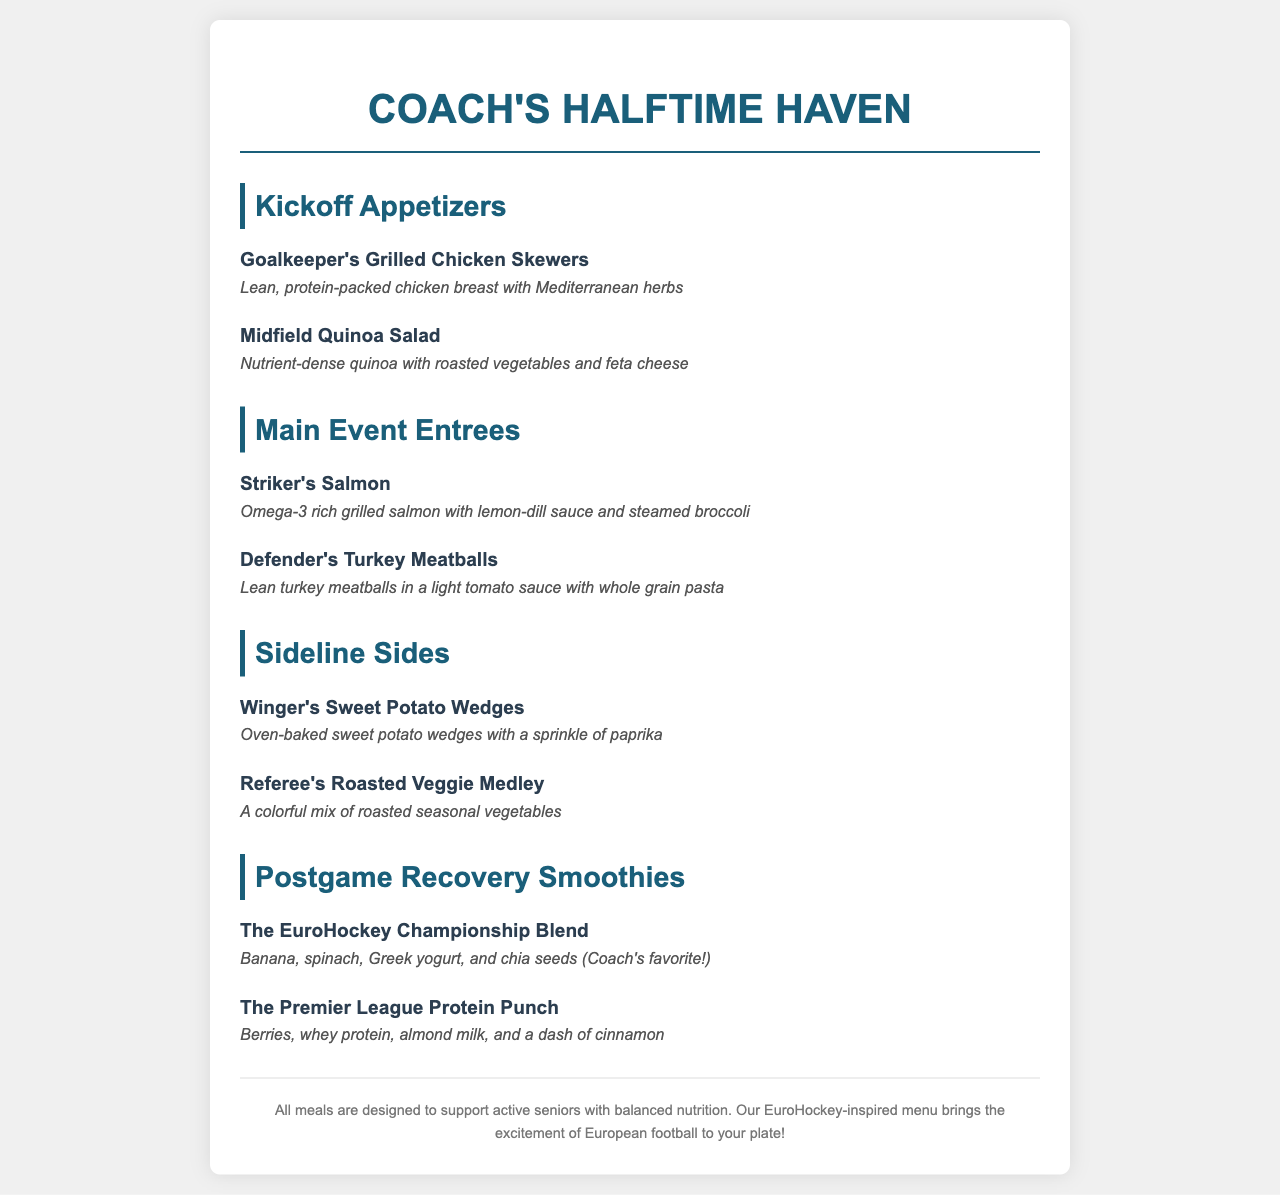What is the title of the menu? The title can be found at the top of the document and reads “Coach's Halftime Haven Menu.”
Answer: Coach's Halftime Haven How many appetizers are listed? The appetizers section contains two items listed under "Kickoff Appetizers".
Answer: 2 What ingredient is in the “Striker's Salmon”? The description mentions omega-3 rich grilled salmon as the main ingredient.
Answer: Salmon What is the name of the smoothie that includes Greek yogurt? The smoothie with Greek yogurt is called "The EuroHockey Championship Blend."
Answer: The EuroHockey Championship Blend Which dish contains whole grain pasta? The “Defender's Turkey Meatballs” includes whole grain pasta in the description.
Answer: Defender's Turkey Meatballs What is the color of the menu title? The color of the menu title is specified in the style section as #1a5f7a.
Answer: #1a5f7a Name one side dish from the menu. The menu provides several side dishes, one of which is "Winger's Sweet Potato Wedges".
Answer: Winger's Sweet Potato Wedges What is the main purpose of the menu? The menu is designed to support active seniors with balanced nutrition.
Answer: Support active seniors 